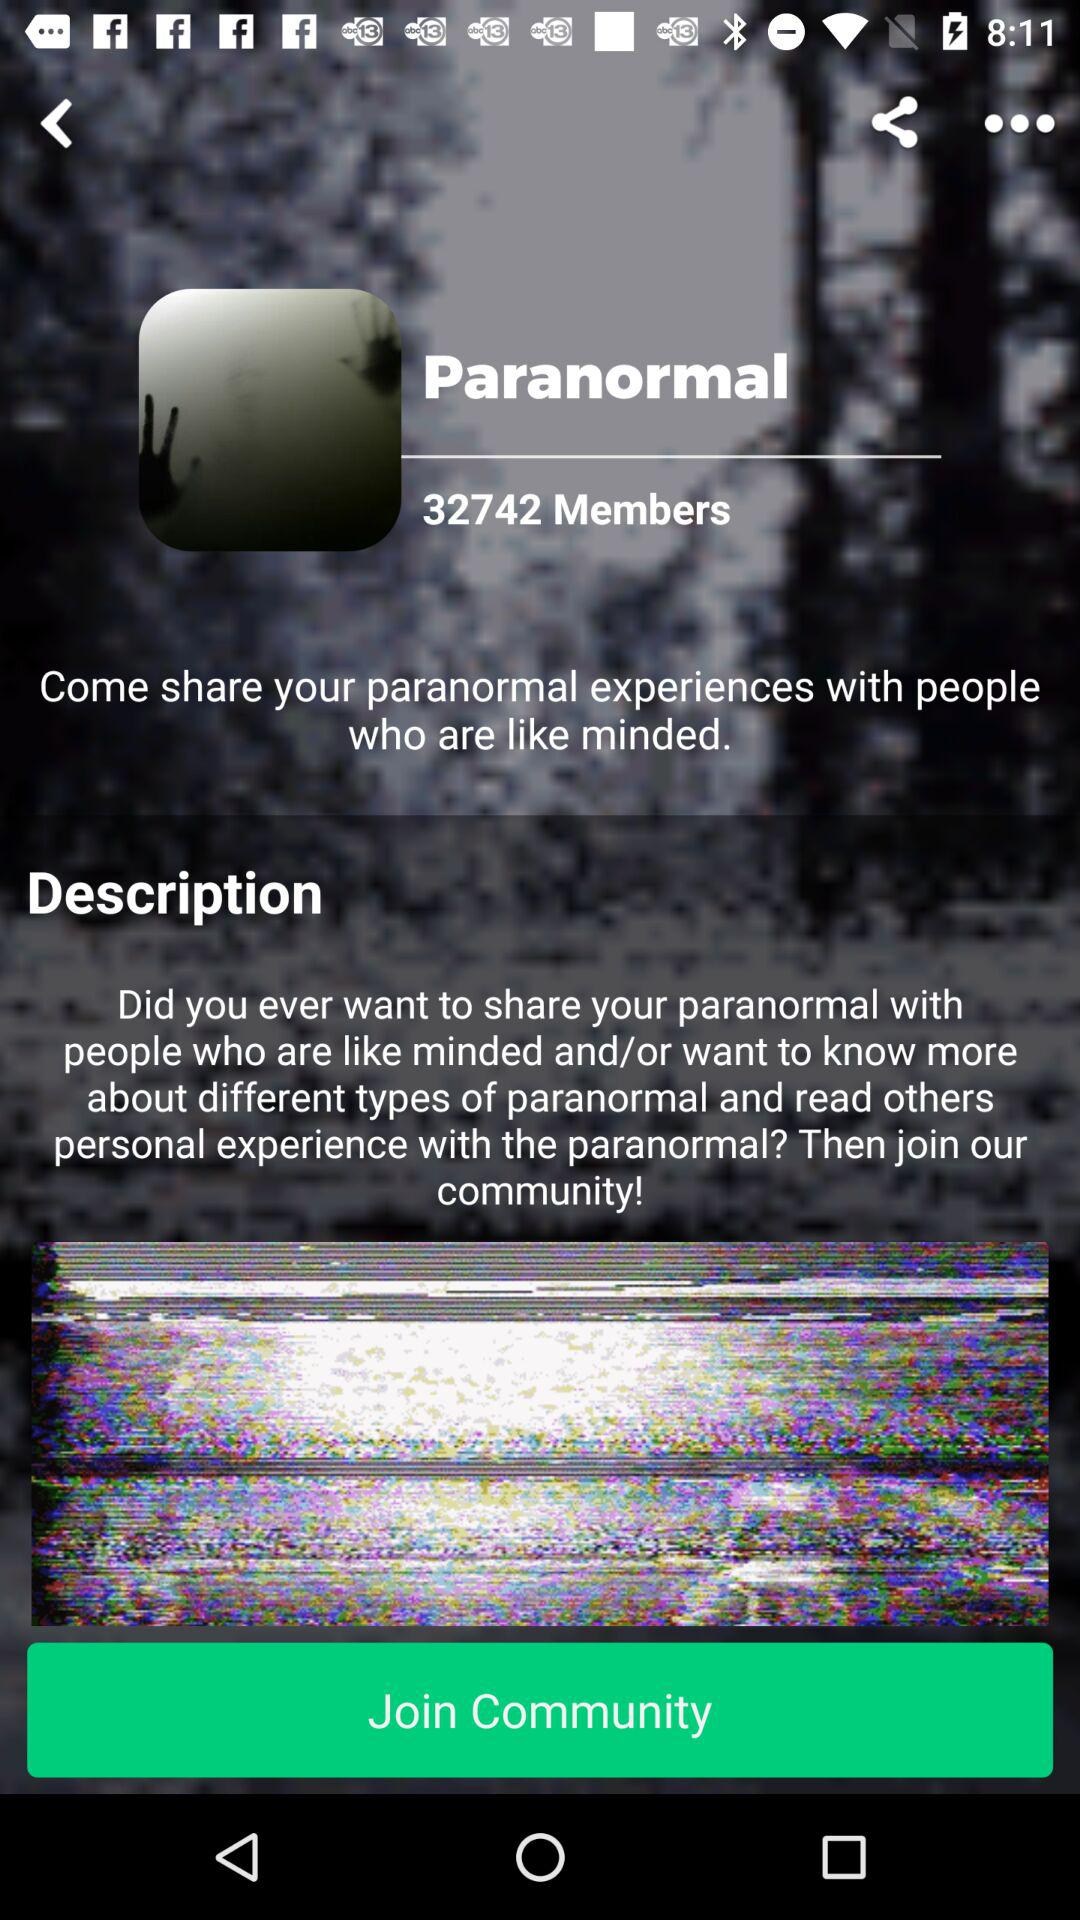What is the name of the application?
When the provided information is insufficient, respond with <no answer>. <no answer> 